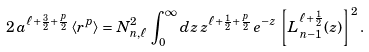<formula> <loc_0><loc_0><loc_500><loc_500>2 \, a ^ { \ell + \frac { 3 } { 2 } + \frac { p } { 2 } } \, \langle r ^ { p } \rangle = N _ { n , \ell } ^ { 2 } \, \int _ { 0 } ^ { \infty } d z \, z ^ { \ell + \frac { 1 } { 2 } + \frac { p } { 2 } } \, e ^ { - z } \, \left [ L _ { n - 1 } ^ { \ell + \frac { 1 } { 2 } } ( z ) \right ] ^ { 2 } .</formula> 